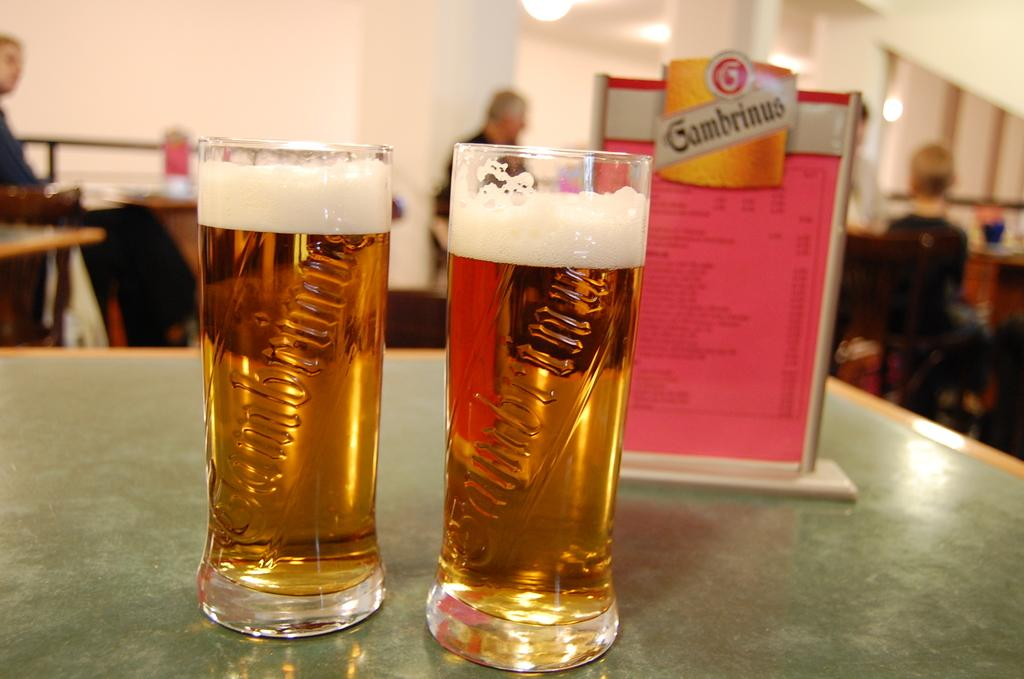<image>
Give a short and clear explanation of the subsequent image. two glasses of beer next to a sign reading Gambrinus 